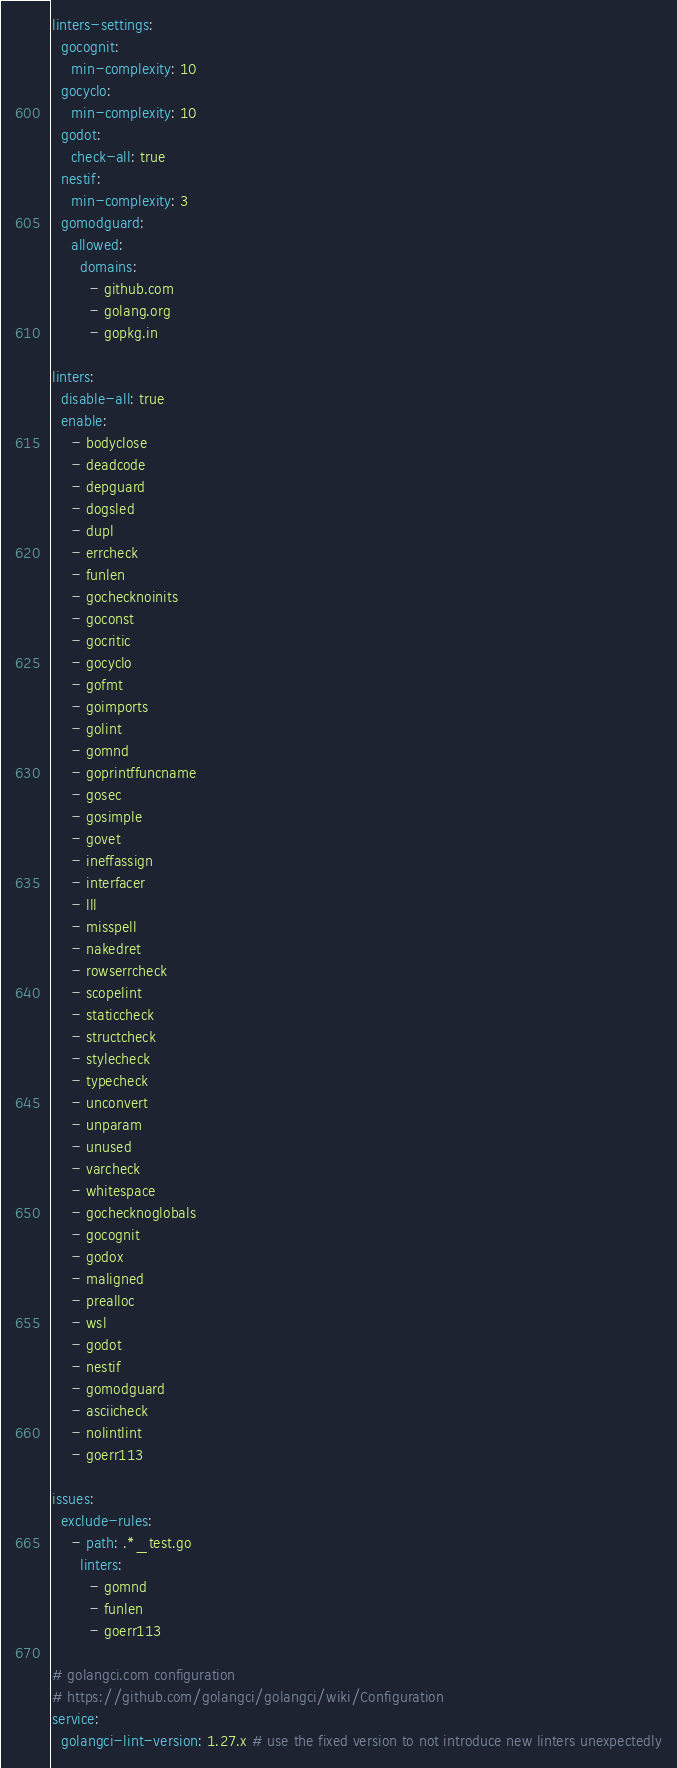Convert code to text. <code><loc_0><loc_0><loc_500><loc_500><_YAML_>linters-settings:
  gocognit:
    min-complexity: 10
  gocyclo:
    min-complexity: 10
  godot:
    check-all: true
  nestif:
    min-complexity: 3
  gomodguard:
    allowed:
      domains:
        - github.com
        - golang.org
        - gopkg.in

linters:
  disable-all: true
  enable:
    - bodyclose
    - deadcode
    - depguard
    - dogsled
    - dupl
    - errcheck
    - funlen
    - gochecknoinits
    - goconst
    - gocritic
    - gocyclo
    - gofmt
    - goimports
    - golint
    - gomnd
    - goprintffuncname
    - gosec
    - gosimple
    - govet
    - ineffassign
    - interfacer
    - lll
    - misspell
    - nakedret
    - rowserrcheck
    - scopelint
    - staticcheck
    - structcheck
    - stylecheck
    - typecheck
    - unconvert
    - unparam
    - unused
    - varcheck
    - whitespace
    - gochecknoglobals
    - gocognit
    - godox
    - maligned
    - prealloc
    - wsl
    - godot
    - nestif
    - gomodguard
    - asciicheck
    - nolintlint
    - goerr113

issues:
  exclude-rules:
    - path: .*_test.go
      linters:
        - gomnd
        - funlen
        - goerr113

# golangci.com configuration
# https://github.com/golangci/golangci/wiki/Configuration
service:
  golangci-lint-version: 1.27.x # use the fixed version to not introduce new linters unexpectedly
</code> 